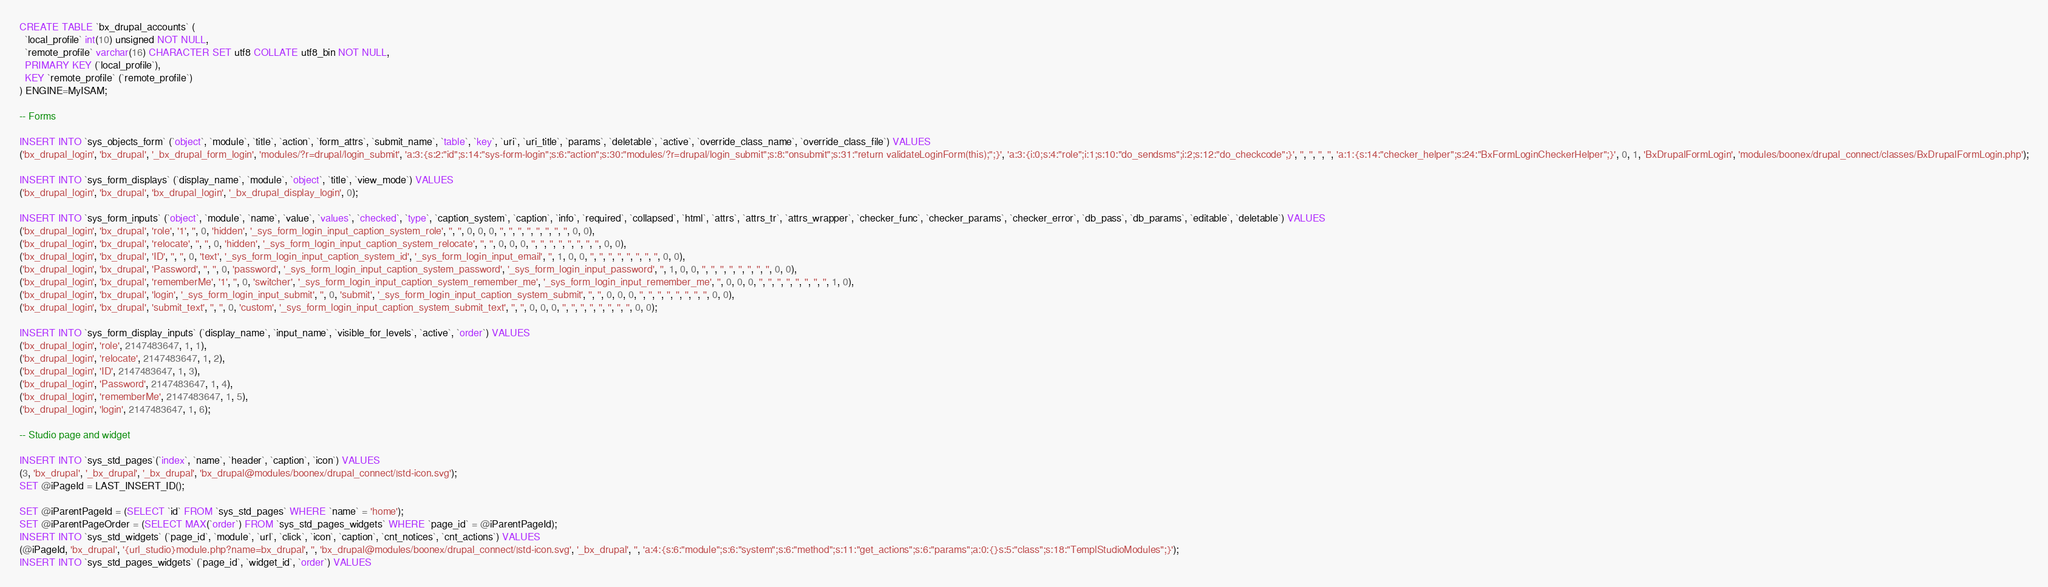<code> <loc_0><loc_0><loc_500><loc_500><_SQL_>
CREATE TABLE `bx_drupal_accounts` (
  `local_profile` int(10) unsigned NOT NULL,
  `remote_profile` varchar(16) CHARACTER SET utf8 COLLATE utf8_bin NOT NULL,
  PRIMARY KEY (`local_profile`),
  KEY `remote_profile` (`remote_profile`)
) ENGINE=MyISAM;

-- Forms

INSERT INTO `sys_objects_form` (`object`, `module`, `title`, `action`, `form_attrs`, `submit_name`, `table`, `key`, `uri`, `uri_title`, `params`, `deletable`, `active`, `override_class_name`, `override_class_file`) VALUES
('bx_drupal_login', 'bx_drupal', '_bx_drupal_form_login', 'modules/?r=drupal/login_submit', 'a:3:{s:2:"id";s:14:"sys-form-login";s:6:"action";s:30:"modules/?r=drupal/login_submit";s:8:"onsubmit";s:31:"return validateLoginForm(this);";}', 'a:3:{i:0;s:4:"role";i:1;s:10:"do_sendsms";i:2;s:12:"do_checkcode";}', '', '', '', '', 'a:1:{s:14:"checker_helper";s:24:"BxFormLoginCheckerHelper";}', 0, 1, 'BxDrupalFormLogin', 'modules/boonex/drupal_connect/classes/BxDrupalFormLogin.php');

INSERT INTO `sys_form_displays` (`display_name`, `module`, `object`, `title`, `view_mode`) VALUES
('bx_drupal_login', 'bx_drupal', 'bx_drupal_login', '_bx_drupal_display_login', 0);

INSERT INTO `sys_form_inputs` (`object`, `module`, `name`, `value`, `values`, `checked`, `type`, `caption_system`, `caption`, `info`, `required`, `collapsed`, `html`, `attrs`, `attrs_tr`, `attrs_wrapper`, `checker_func`, `checker_params`, `checker_error`, `db_pass`, `db_params`, `editable`, `deletable`) VALUES
('bx_drupal_login', 'bx_drupal', 'role', '1', '', 0, 'hidden', '_sys_form_login_input_caption_system_role', '', '', 0, 0, 0, '', '', '', '', '', '', '', '', 0, 0),
('bx_drupal_login', 'bx_drupal', 'relocate', '', '', 0, 'hidden', '_sys_form_login_input_caption_system_relocate', '', '', 0, 0, 0, '', '', '', '', '', '', '', '', 0, 0),
('bx_drupal_login', 'bx_drupal', 'ID', '', '', 0, 'text', '_sys_form_login_input_caption_system_id', '_sys_form_login_input_email', '', 1, 0, 0, '', '', '', '', '', '', '', '', 0, 0),
('bx_drupal_login', 'bx_drupal', 'Password', '', '', 0, 'password', '_sys_form_login_input_caption_system_password', '_sys_form_login_input_password', '', 1, 0, 0, '', '', '', '', '', '', '', '', 0, 0),
('bx_drupal_login', 'bx_drupal', 'rememberMe', '1', '', 0, 'switcher', '_sys_form_login_input_caption_system_remember_me', '_sys_form_login_input_remember_me', '', 0, 0, 0, '', '', '', '', '', '', '', '', 1, 0),
('bx_drupal_login', 'bx_drupal', 'login', '_sys_form_login_input_submit', '', 0, 'submit', '_sys_form_login_input_caption_system_submit', '', '', 0, 0, 0, '', '', '', '', '', '', '', '', 0, 0),
('bx_drupal_login', 'bx_drupal', 'submit_text', '', '', 0, 'custom', '_sys_form_login_input_caption_system_submit_text', '', '', 0, 0, 0, '', '', '', '', '', '', '', '', 0, 0);

INSERT INTO `sys_form_display_inputs` (`display_name`, `input_name`, `visible_for_levels`, `active`, `order`) VALUES
('bx_drupal_login', 'role', 2147483647, 1, 1),
('bx_drupal_login', 'relocate', 2147483647, 1, 2),
('bx_drupal_login', 'ID', 2147483647, 1, 3),
('bx_drupal_login', 'Password', 2147483647, 1, 4),
('bx_drupal_login', 'rememberMe', 2147483647, 1, 5),
('bx_drupal_login', 'login', 2147483647, 1, 6);

-- Studio page and widget

INSERT INTO `sys_std_pages`(`index`, `name`, `header`, `caption`, `icon`) VALUES
(3, 'bx_drupal', '_bx_drupal', '_bx_drupal', 'bx_drupal@modules/boonex/drupal_connect/|std-icon.svg');
SET @iPageId = LAST_INSERT_ID();

SET @iParentPageId = (SELECT `id` FROM `sys_std_pages` WHERE `name` = 'home');
SET @iParentPageOrder = (SELECT MAX(`order`) FROM `sys_std_pages_widgets` WHERE `page_id` = @iParentPageId);
INSERT INTO `sys_std_widgets` (`page_id`, `module`, `url`, `click`, `icon`, `caption`, `cnt_notices`, `cnt_actions`) VALUES
(@iPageId, 'bx_drupal', '{url_studio}module.php?name=bx_drupal', '', 'bx_drupal@modules/boonex/drupal_connect/|std-icon.svg', '_bx_drupal', '', 'a:4:{s:6:"module";s:6:"system";s:6:"method";s:11:"get_actions";s:6:"params";a:0:{}s:5:"class";s:18:"TemplStudioModules";}');
INSERT INTO `sys_std_pages_widgets` (`page_id`, `widget_id`, `order`) VALUES</code> 